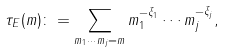<formula> <loc_0><loc_0><loc_500><loc_500>\tau _ { E } ( m ) \colon = \sum _ { m _ { 1 } \cdots m _ { j } = m } m _ { 1 } ^ { - \xi _ { 1 } } \cdots m _ { j } ^ { - \xi _ { j } } ,</formula> 